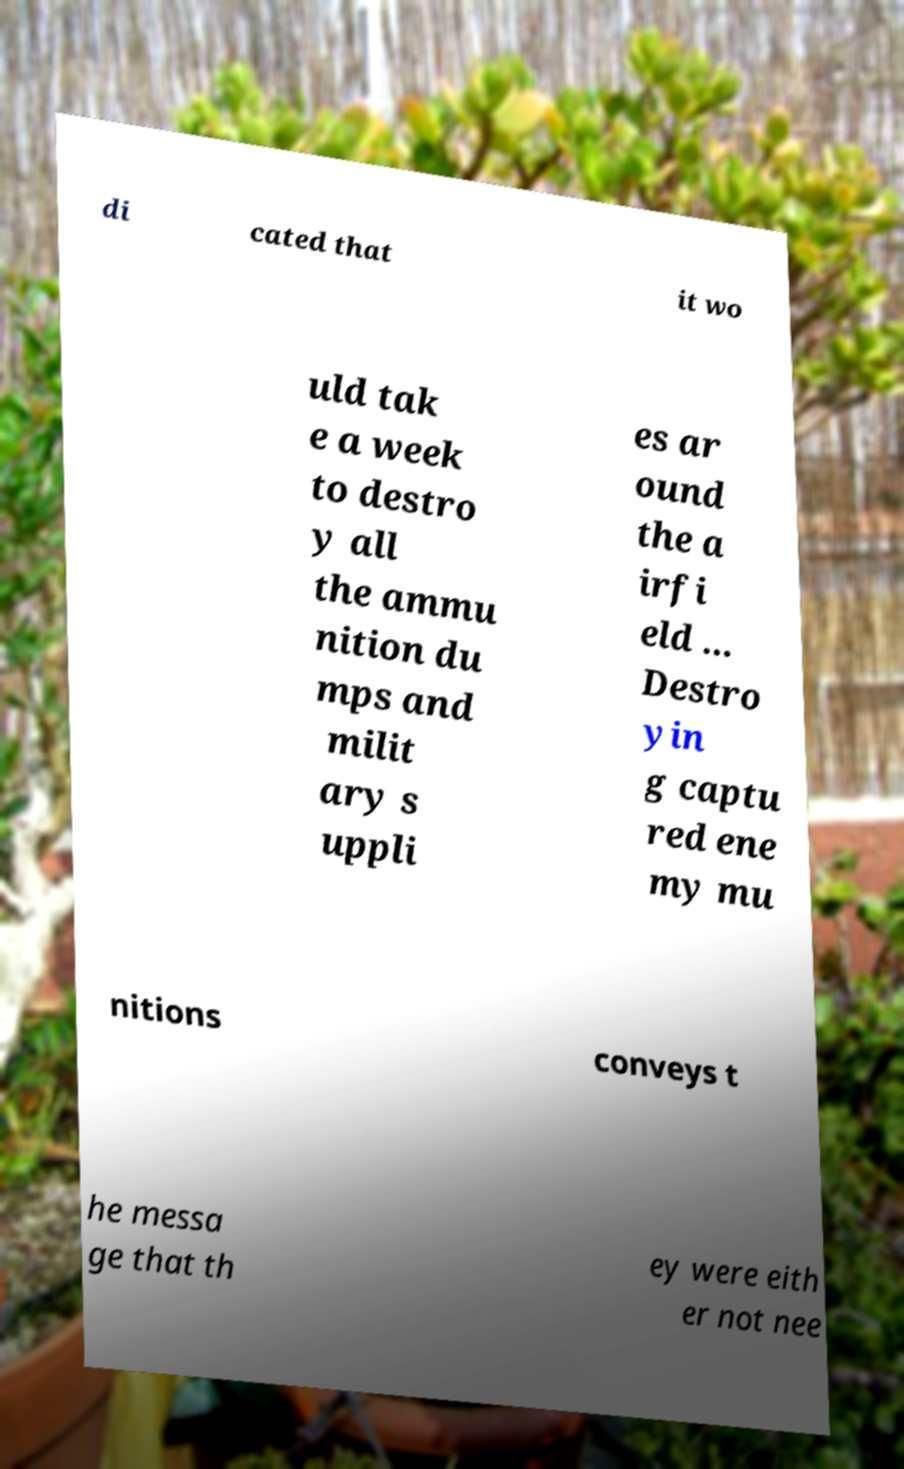Please read and relay the text visible in this image. What does it say? di cated that it wo uld tak e a week to destro y all the ammu nition du mps and milit ary s uppli es ar ound the a irfi eld ... Destro yin g captu red ene my mu nitions conveys t he messa ge that th ey were eith er not nee 